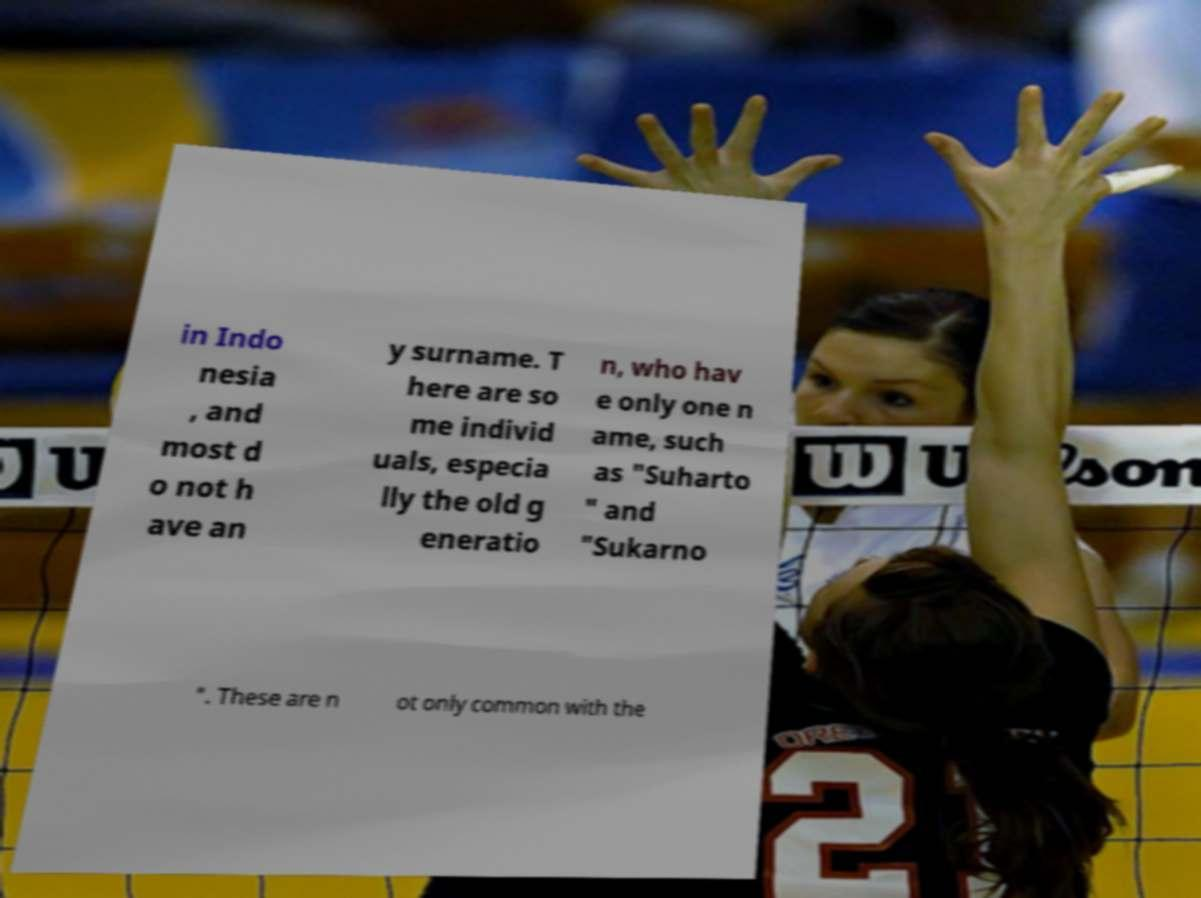Please identify and transcribe the text found in this image. in Indo nesia , and most d o not h ave an y surname. T here are so me individ uals, especia lly the old g eneratio n, who hav e only one n ame, such as "Suharto " and "Sukarno ". These are n ot only common with the 